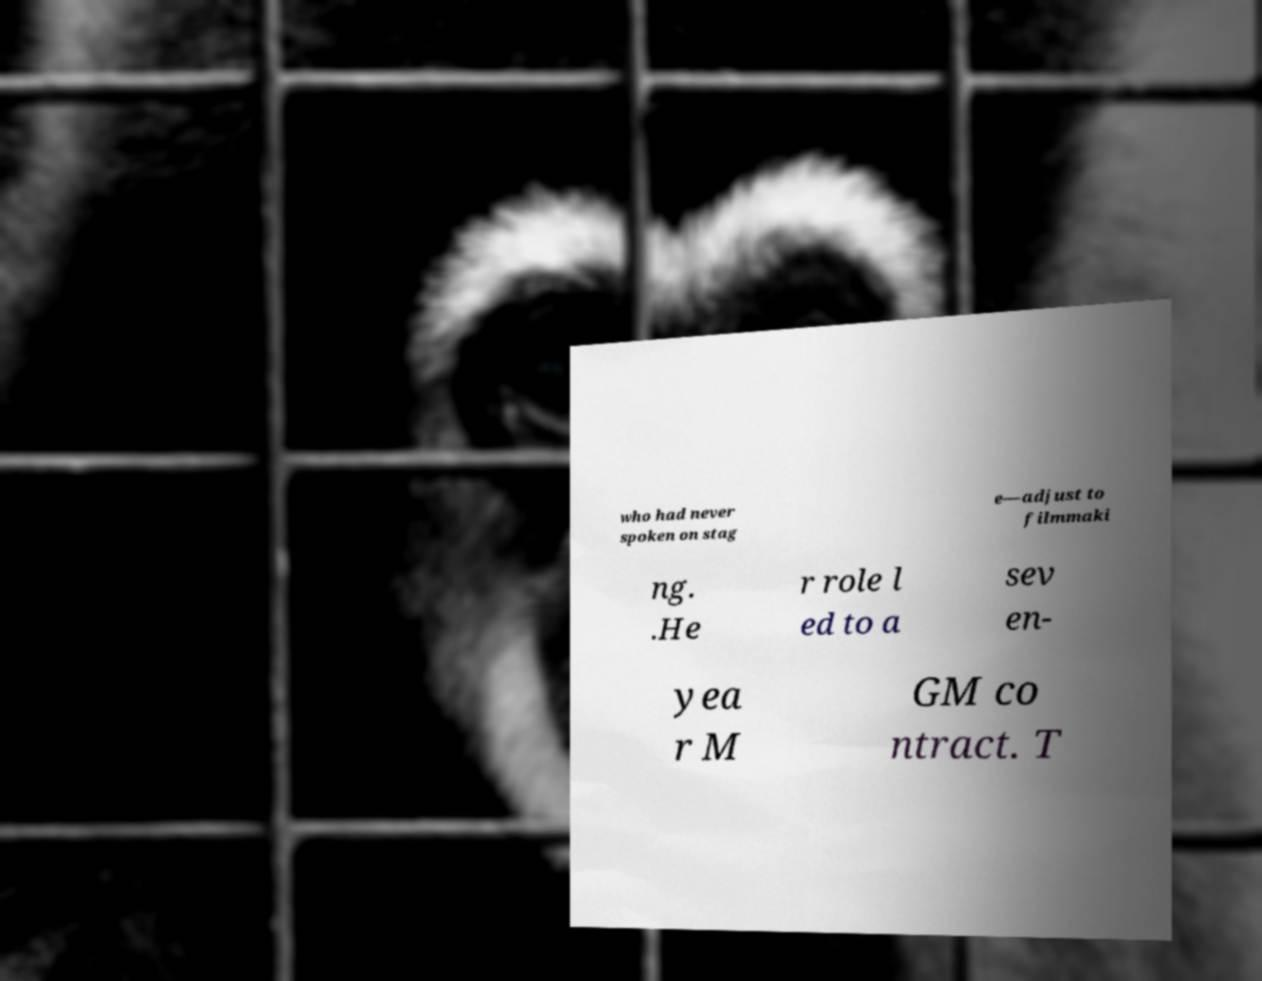There's text embedded in this image that I need extracted. Can you transcribe it verbatim? who had never spoken on stag e—adjust to filmmaki ng. .He r role l ed to a sev en- yea r M GM co ntract. T 